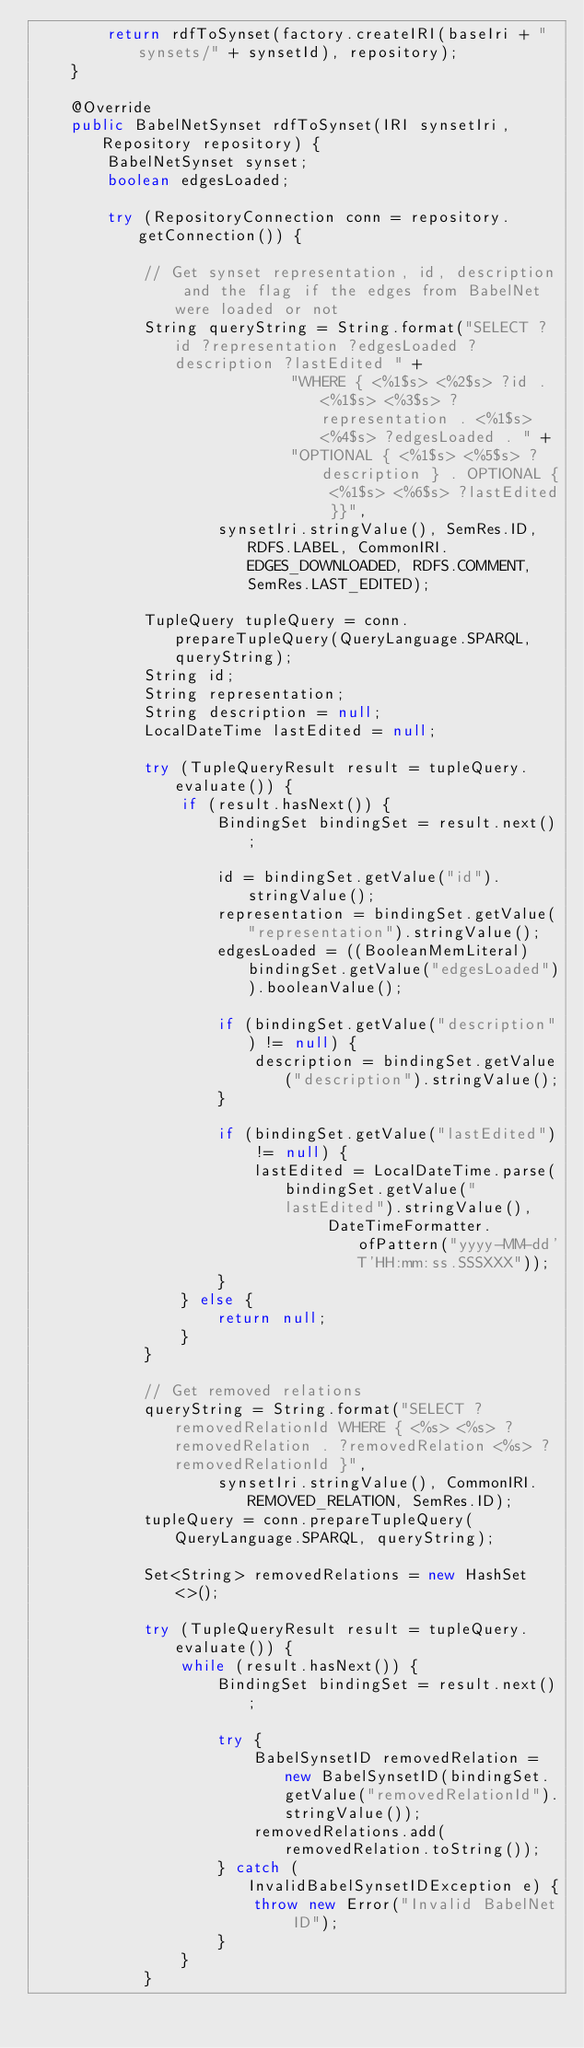<code> <loc_0><loc_0><loc_500><loc_500><_Java_>        return rdfToSynset(factory.createIRI(baseIri + "synsets/" + synsetId), repository);
    }

    @Override
    public BabelNetSynset rdfToSynset(IRI synsetIri, Repository repository) {
        BabelNetSynset synset;
        boolean edgesLoaded;

        try (RepositoryConnection conn = repository.getConnection()) {

            // Get synset representation, id, description and the flag if the edges from BabelNet were loaded or not
            String queryString = String.format("SELECT ?id ?representation ?edgesLoaded ?description ?lastEdited " +
                            "WHERE { <%1$s> <%2$s> ?id . <%1$s> <%3$s> ?representation . <%1$s> <%4$s> ?edgesLoaded . " +
                            "OPTIONAL { <%1$s> <%5$s> ?description } . OPTIONAL { <%1$s> <%6$s> ?lastEdited }}",
                    synsetIri.stringValue(), SemRes.ID, RDFS.LABEL, CommonIRI.EDGES_DOWNLOADED, RDFS.COMMENT, SemRes.LAST_EDITED);

            TupleQuery tupleQuery = conn.prepareTupleQuery(QueryLanguage.SPARQL, queryString);
            String id;
            String representation;
            String description = null;
            LocalDateTime lastEdited = null;

            try (TupleQueryResult result = tupleQuery.evaluate()) {
                if (result.hasNext()) {
                    BindingSet bindingSet = result.next();

                    id = bindingSet.getValue("id").stringValue();
                    representation = bindingSet.getValue("representation").stringValue();
                    edgesLoaded = ((BooleanMemLiteral) bindingSet.getValue("edgesLoaded")).booleanValue();

                    if (bindingSet.getValue("description") != null) {
                        description = bindingSet.getValue("description").stringValue();
                    }

                    if (bindingSet.getValue("lastEdited") != null) {
                        lastEdited = LocalDateTime.parse(bindingSet.getValue("lastEdited").stringValue(),
                                DateTimeFormatter.ofPattern("yyyy-MM-dd'T'HH:mm:ss.SSSXXX"));
                    }
                } else {
                    return null;
                }
            }

            // Get removed relations
            queryString = String.format("SELECT ?removedRelationId WHERE { <%s> <%s> ?removedRelation . ?removedRelation <%s> ?removedRelationId }",
                    synsetIri.stringValue(), CommonIRI.REMOVED_RELATION, SemRes.ID);
            tupleQuery = conn.prepareTupleQuery(QueryLanguage.SPARQL, queryString);

            Set<String> removedRelations = new HashSet<>();

            try (TupleQueryResult result = tupleQuery.evaluate()) {
                while (result.hasNext()) {
                    BindingSet bindingSet = result.next();

                    try {
                        BabelSynsetID removedRelation = new BabelSynsetID(bindingSet.getValue("removedRelationId").stringValue());
                        removedRelations.add(removedRelation.toString());
                    } catch (InvalidBabelSynsetIDException e) {
                        throw new Error("Invalid BabelNet ID");
                    }
                }
            }
</code> 